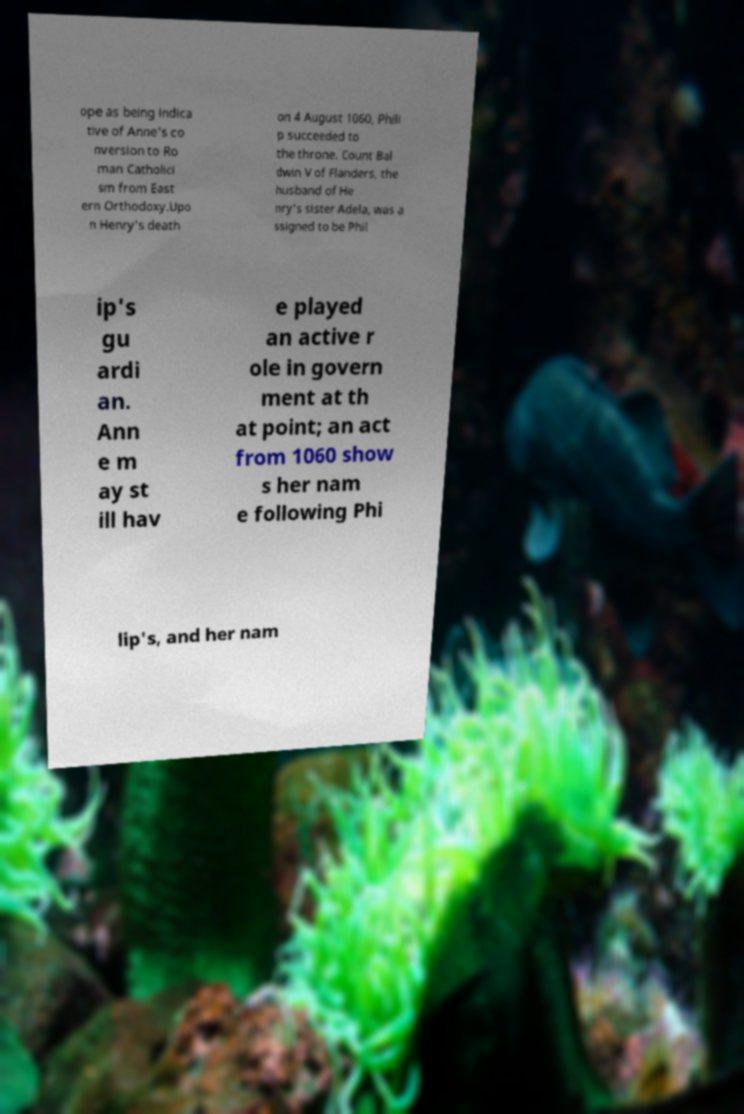For documentation purposes, I need the text within this image transcribed. Could you provide that? ope as being indica tive of Anne's co nversion to Ro man Catholici sm from East ern Orthodoxy.Upo n Henry's death on 4 August 1060, Phili p succeeded to the throne. Count Bal dwin V of Flanders, the husband of He nry's sister Adela, was a ssigned to be Phil ip's gu ardi an. Ann e m ay st ill hav e played an active r ole in govern ment at th at point; an act from 1060 show s her nam e following Phi lip's, and her nam 